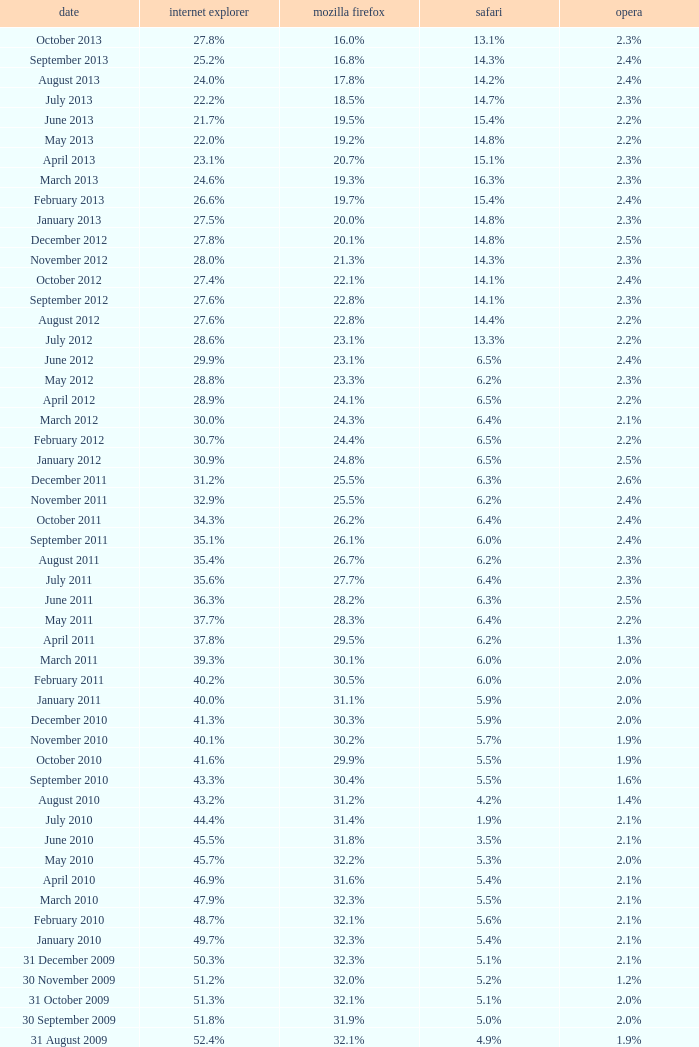What is the date when internet explorer was 62.2% 31 January 2008. 